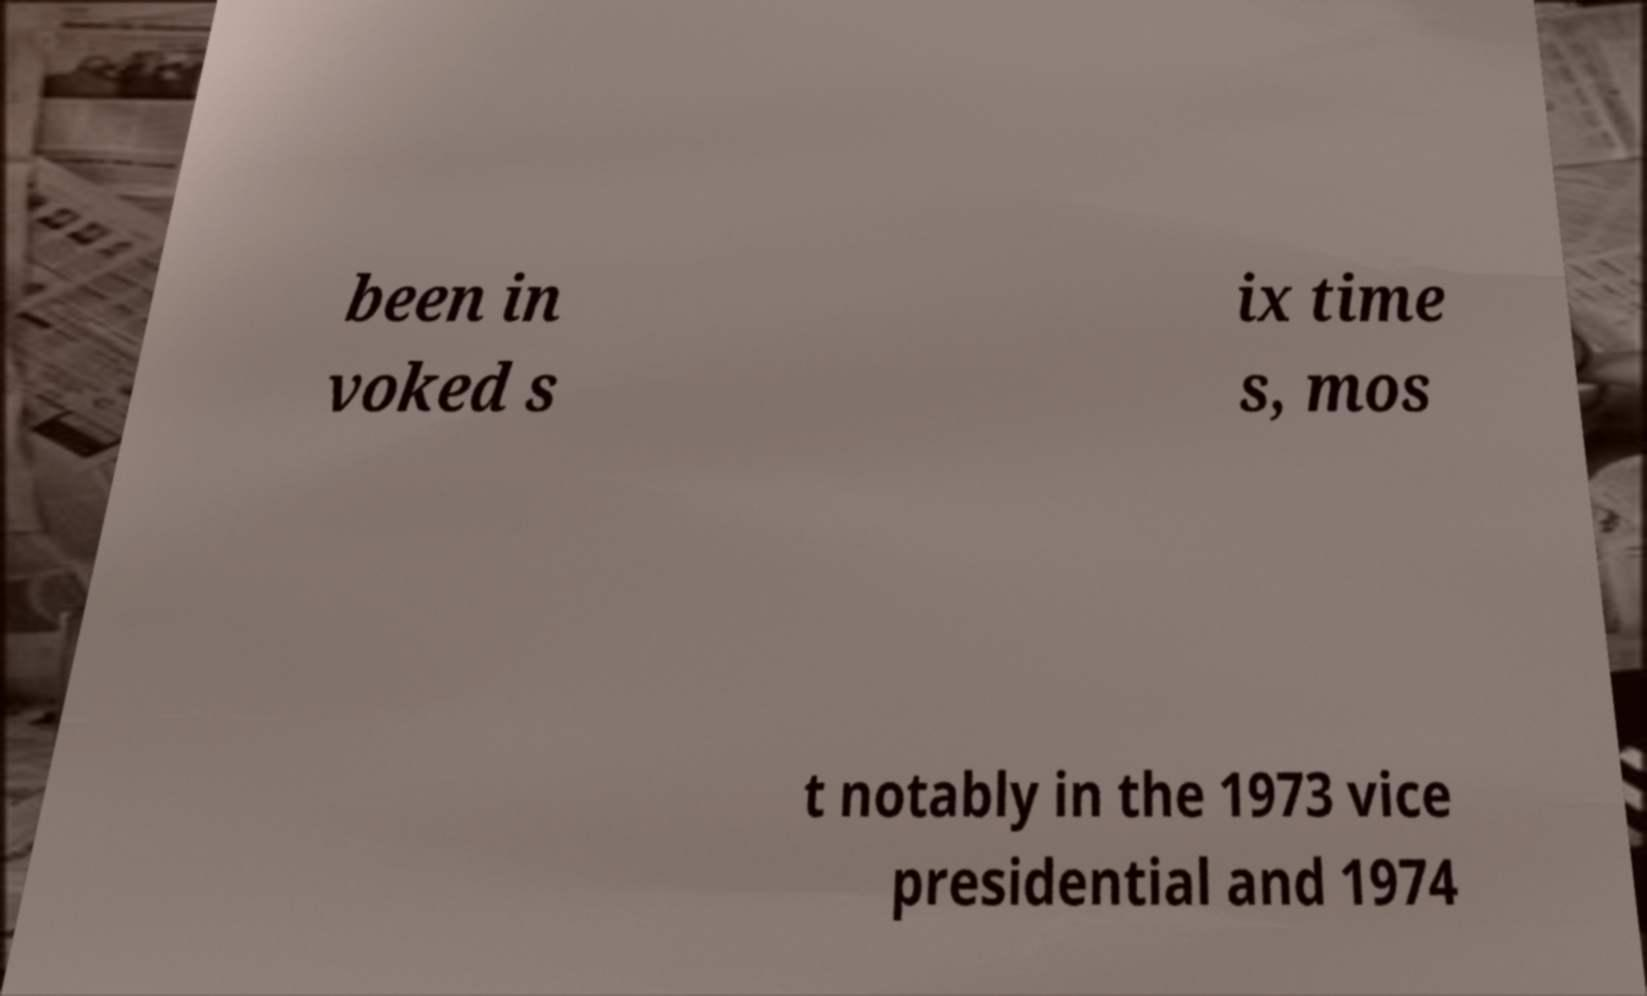Please identify and transcribe the text found in this image. been in voked s ix time s, mos t notably in the 1973 vice presidential and 1974 